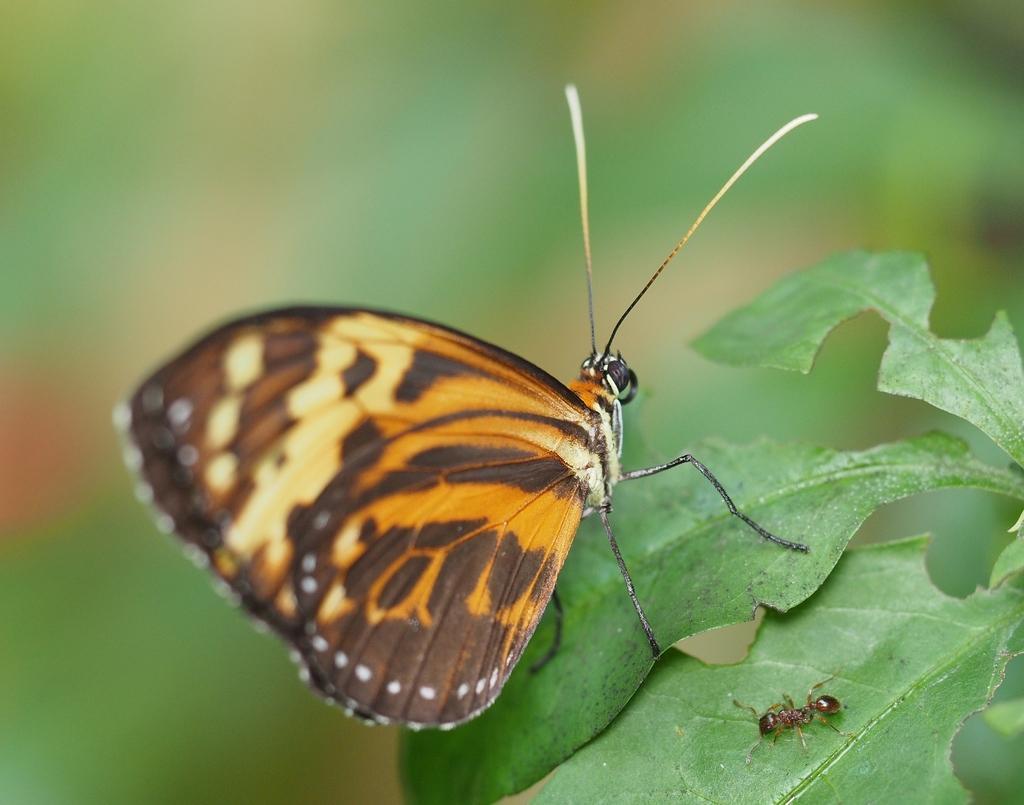How would you summarize this image in a sentence or two? In the center of the image we can see leaves. On the leaves, we can see one ant and one butterfly, which is in black and yellow color. 